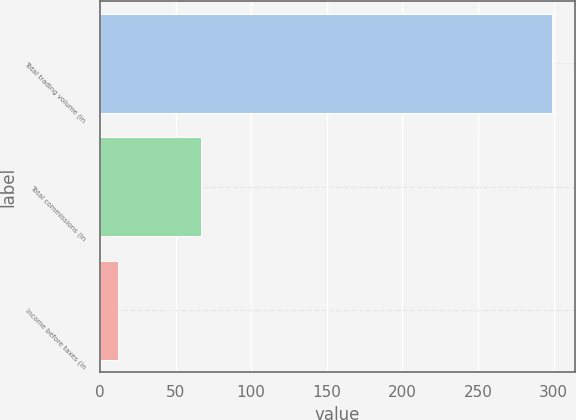<chart> <loc_0><loc_0><loc_500><loc_500><bar_chart><fcel>Total trading volume (in<fcel>Total commissions (in<fcel>Income before taxes (in<nl><fcel>299.2<fcel>66.9<fcel>11.6<nl></chart> 